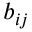<formula> <loc_0><loc_0><loc_500><loc_500>b _ { i j }</formula> 